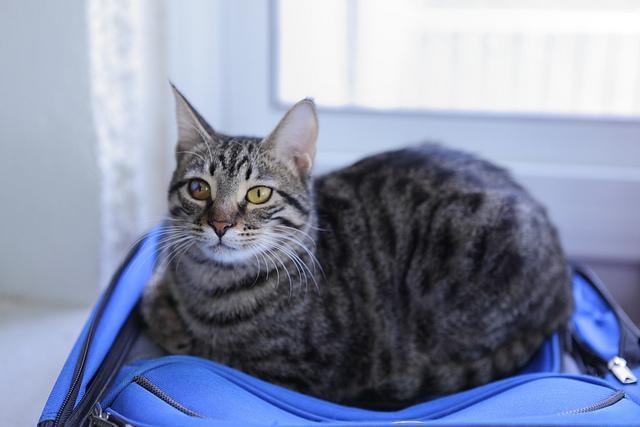How many orange signs are there?
Give a very brief answer. 0. 